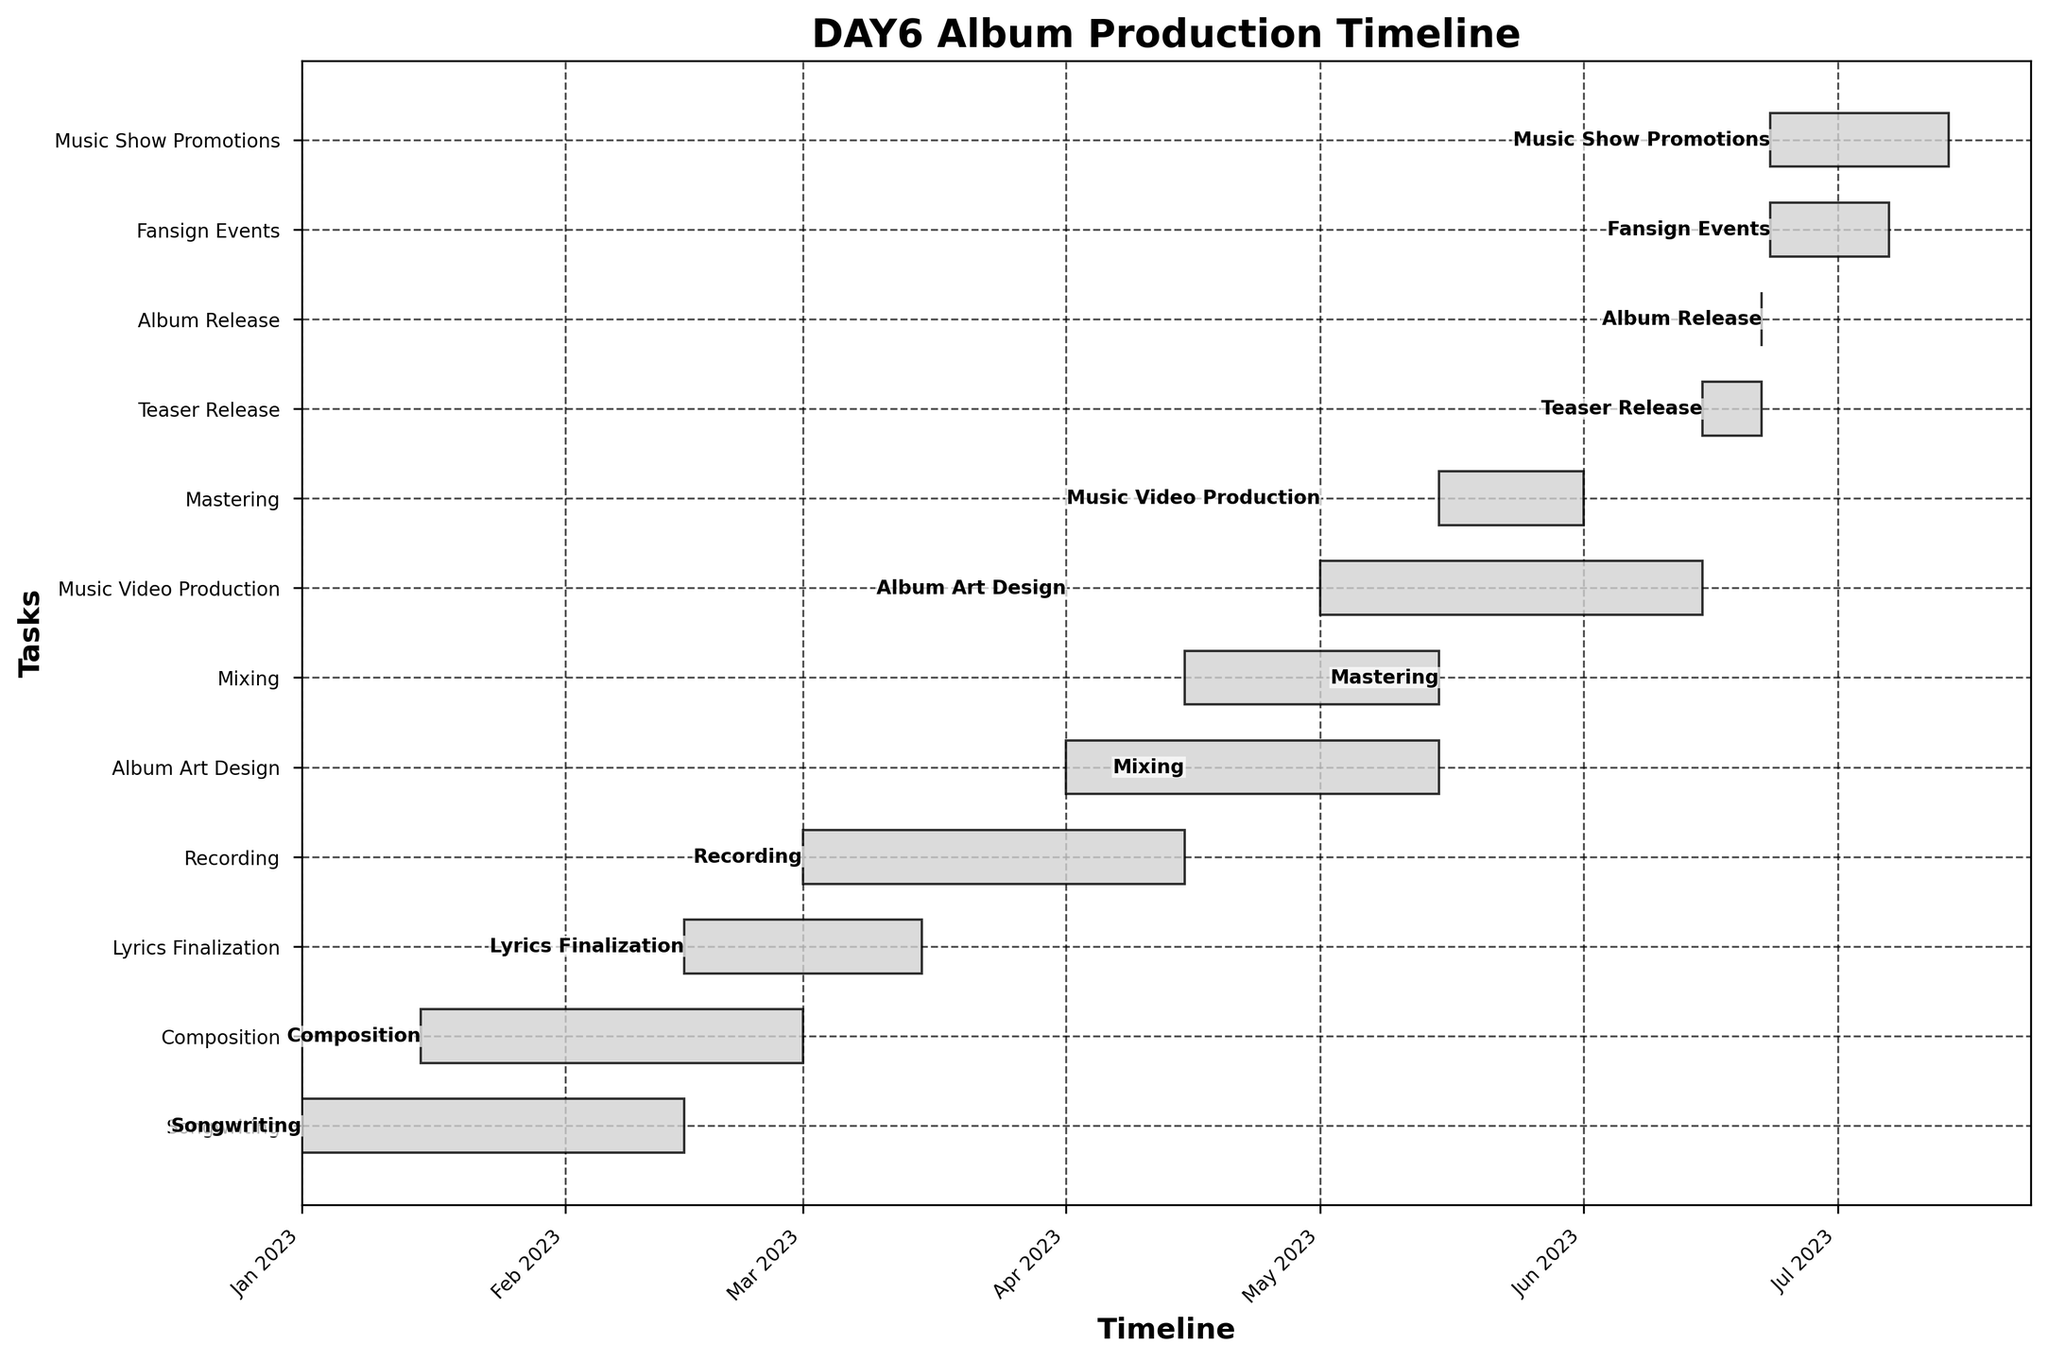What is the title of the Gantt Chart? The title of a plot is usually located at the top of the figure, making it one of the most noticeable elements.
Answer: DAY6 Album Production Timeline What is the first task in the DAY6 album production timeline? The first task is determined by looking at the earliest start date in the timeline. The task with the start date of 2023-01-01 is the first.
Answer: Songwriting How long is the "Recording" phase? To find the duration of the "Recording" phase, subtract the start date (2023-03-01) from the end date (2023-04-15). Calculate the difference in days.
Answer: 45 days Which task overlaps with the "Album Art Design" phase and by how many days? To determine which task overlaps, look at the start and end dates of "Album Art Design" (2023-04-01 to 2023-05-15) and compare them with the other tasks. Both "Mixing" (overlaps from 2023-04-15 to 2023-05-15) and "Recording" (overlaps from 2023-04-01 to 2023-04-15) overlap. The overlapping days with each task need to be calculated.
Answer: Mixing: 30 days; Recording: 15 days Which task has the shortest duration within the timeline? Find the task duration by comparing the difference between start and end dates for each task. Identify the one with the smallest number of days.
Answer: Album Release How many tasks start in April 2023? Check all tasks and count the number of tasks with start dates in April 2023. The tasks are clearly labeled by their start dates.
Answer: 2 tasks Which tasks run concurrently with the "Music Video Production"? "Music Video Production" runs from 2023-05-01 to 2023-06-15. Identify all tasks with overlapping start and end dates within this period.
Answer: Mixing, Mastering, Album Art Design, Teaser Release How many days does it take from the start of "Songwriting" to the "Album Release"? Calculate the total duration by finding the difference between the start date of "Songwriting" (2023-01-01) and the date of "Album Release" (2023-06-22). Compute in days.
Answer: 172 days What are the two tasks that immediately follow the "Album Release"? Identify which tasks start immediately after the "Album Release" date of 2023-06-22. These should be the ones with start dates on 2023-06-23.
Answer: Fansign Events, Music Show Promotions Can you list the tasks that finish in May 2023? To find tasks that finish in May 2023, identify tasks with end dates in that month. Look for tasks ending between 2023-05-01 and 2023-05-31.
Answer: Mixing, Album Art Design 